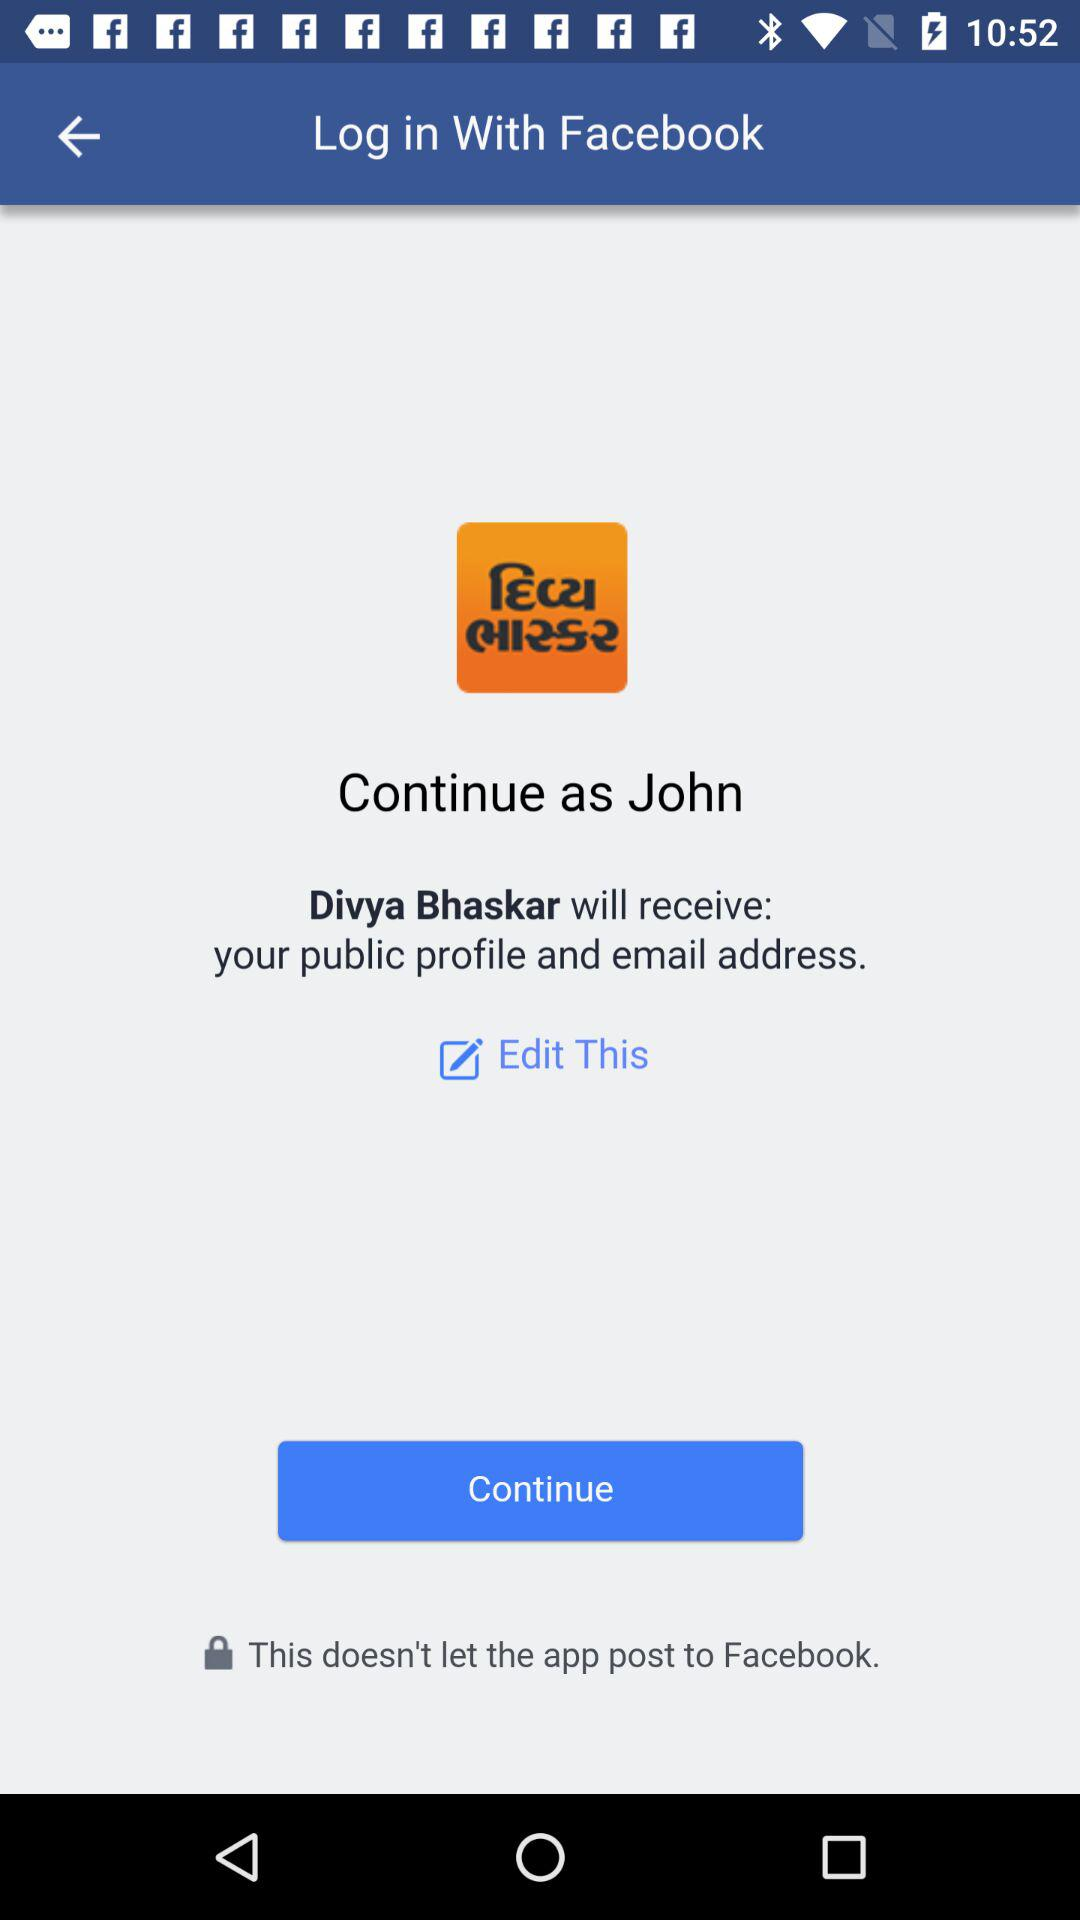What is the log in name? The log in name is John. 